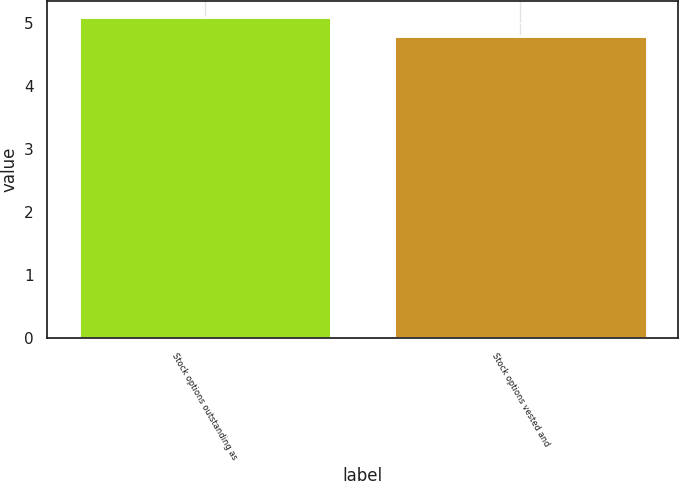<chart> <loc_0><loc_0><loc_500><loc_500><bar_chart><fcel>Stock options outstanding as<fcel>Stock options vested and<nl><fcel>5.1<fcel>4.8<nl></chart> 